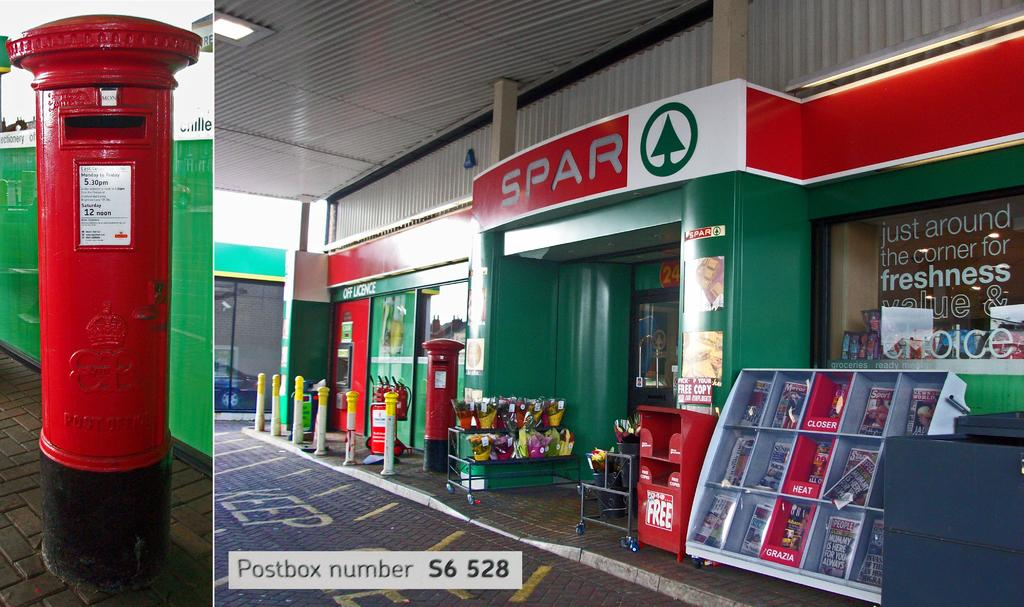<image>
Offer a succinct explanation of the picture presented. A Spar store  the the slogan just around the corner for freshness in the window. 